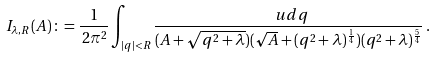Convert formula to latex. <formula><loc_0><loc_0><loc_500><loc_500>I _ { \lambda , R } ( A ) \, \colon = \frac { 1 } { \, 2 \pi ^ { 2 } } \int _ { | q | < R } \frac { \ u d q } { ( A + \sqrt { q ^ { 2 } + \lambda } ) ( \sqrt { A } + ( q ^ { 2 } + \lambda ) ^ { \frac { 1 } { 4 } } ) ( q ^ { 2 } + \lambda ) ^ { \frac { 5 } { 4 } } } \, .</formula> 